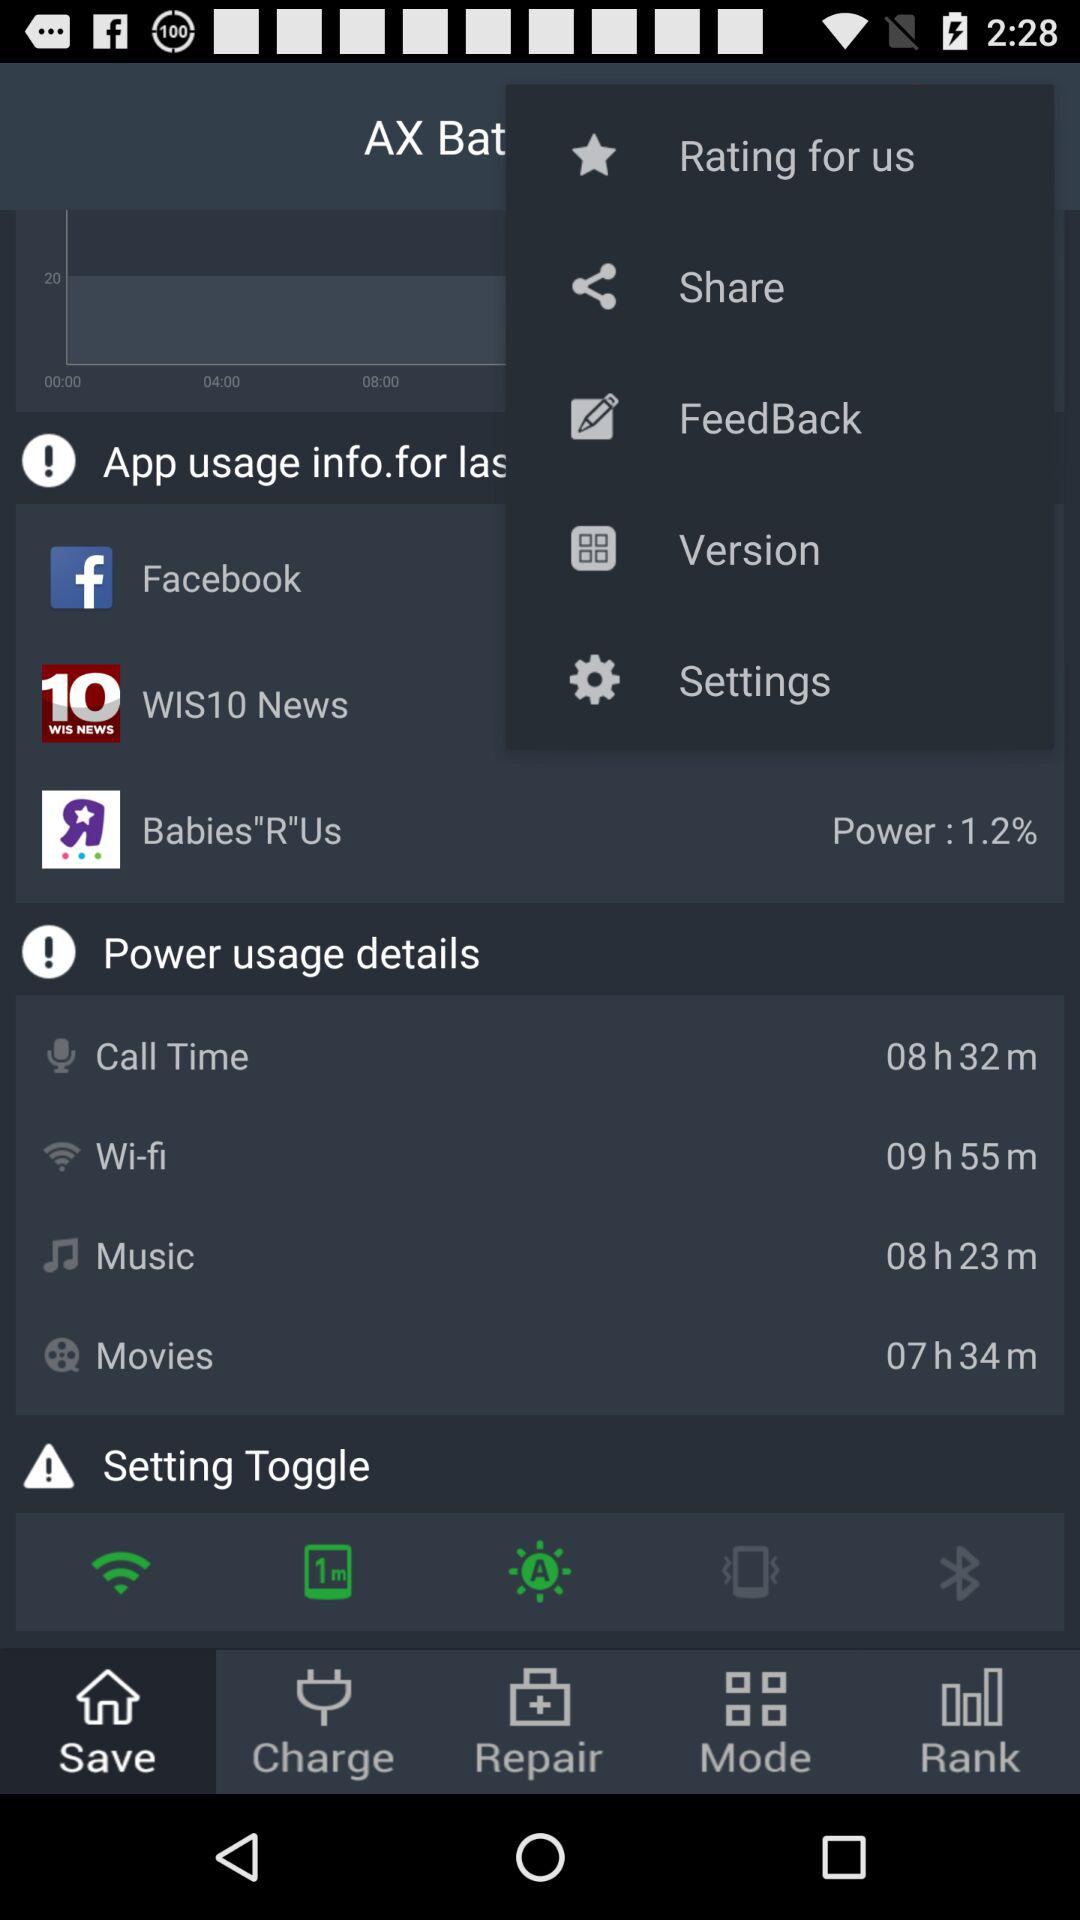What duration is mentioned for movies in "Power usage details"? The mentioned duration is 7 hours and 34 minutes. 